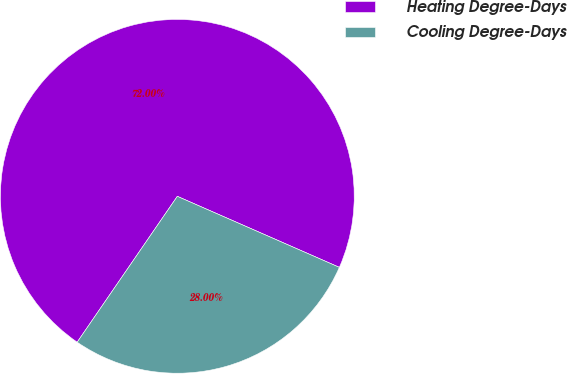Convert chart to OTSL. <chart><loc_0><loc_0><loc_500><loc_500><pie_chart><fcel>Heating Degree-Days<fcel>Cooling Degree-Days<nl><fcel>72.0%<fcel>28.0%<nl></chart> 